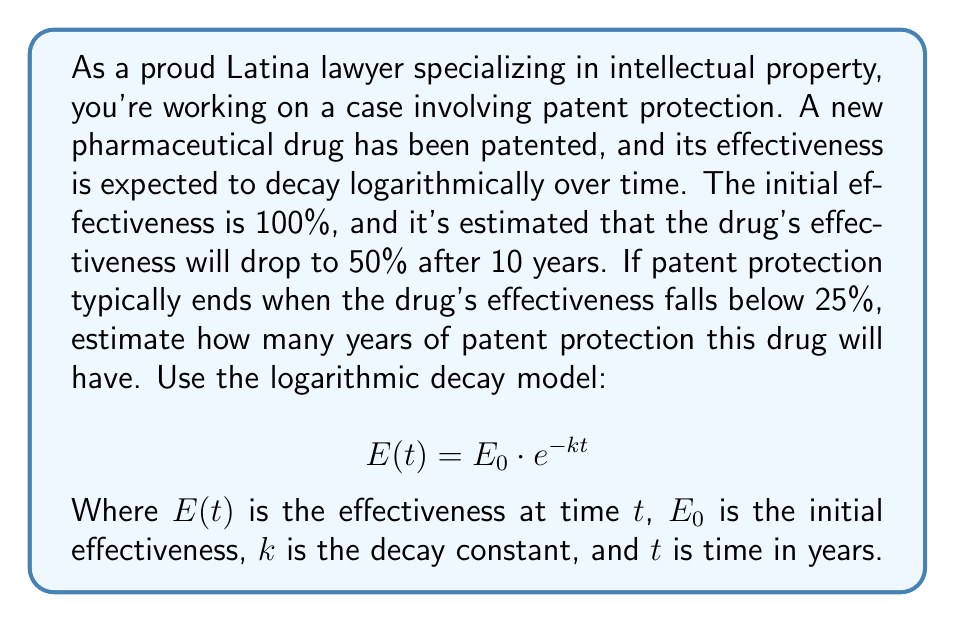Could you help me with this problem? Let's approach this step-by-step:

1) First, we need to find the decay constant $k$ using the given information:
   At $t = 10$ years, $E(10) = 50\%$ of $E_0$

   $$ 0.5E_0 = E_0 \cdot e^{-k \cdot 10} $$

2) Simplify:
   $$ 0.5 = e^{-10k} $$

3) Take the natural log of both sides:
   $$ \ln(0.5) = -10k $$

4) Solve for $k$:
   $$ k = -\frac{\ln(0.5)}{10} \approx 0.0693 $$

5) Now, we want to find $t$ when $E(t) = 25\%$ of $E_0$:
   $$ 0.25E_0 = E_0 \cdot e^{-0.0693t} $$

6) Simplify:
   $$ 0.25 = e^{-0.0693t} $$

7) Take the natural log of both sides:
   $$ \ln(0.25) = -0.0693t $$

8) Solve for $t$:
   $$ t = -\frac{\ln(0.25)}{0.0693} \approx 19.9 \text{ years} $$

Therefore, the patent protection will last approximately 20 years.
Answer: The drug will have approximately 20 years of patent protection. 